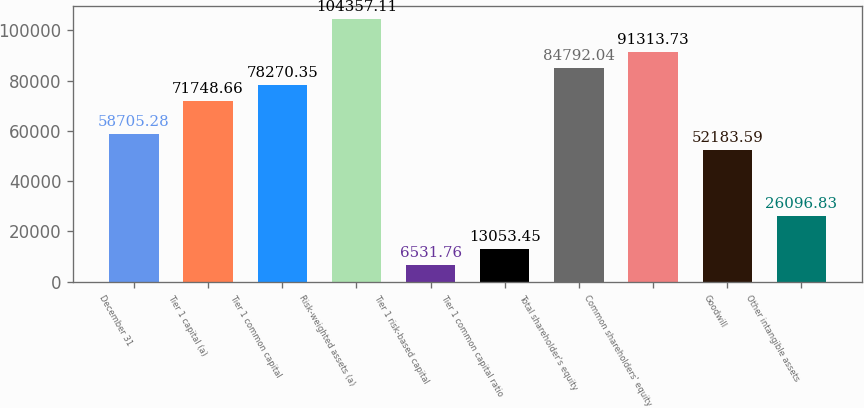Convert chart to OTSL. <chart><loc_0><loc_0><loc_500><loc_500><bar_chart><fcel>December 31<fcel>Tier 1 capital (a)<fcel>Tier 1 common capital<fcel>Risk-weighted assets (a)<fcel>Tier 1 risk-based capital<fcel>Tier 1 common capital ratio<fcel>Total shareholder's equity<fcel>Common shareholders' equity<fcel>Goodwill<fcel>Other intangible assets<nl><fcel>58705.3<fcel>71748.7<fcel>78270.4<fcel>104357<fcel>6531.76<fcel>13053.5<fcel>84792<fcel>91313.7<fcel>52183.6<fcel>26096.8<nl></chart> 